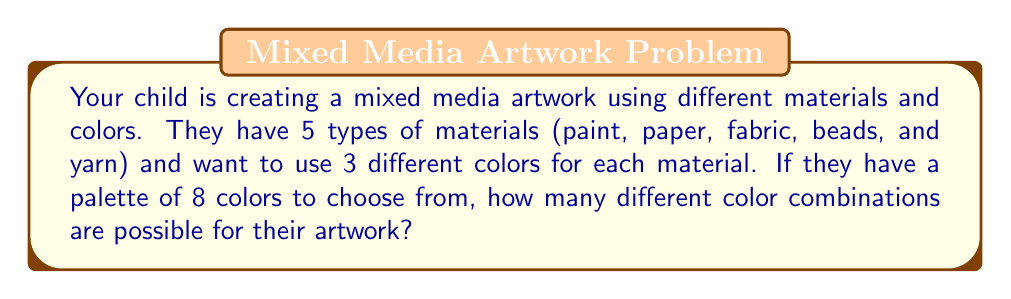Can you answer this question? Let's break this down step-by-step:

1) For each material, your child needs to choose 3 colors out of 8 available colors.

2) This is a combination problem, as the order of selection doesn't matter (e.g., choosing red, blue, green is the same as blue, green, red for a given material).

3) The number of ways to choose 3 colors out of 8 is given by the combination formula:

   $$\binom{8}{3} = \frac{8!}{3!(8-3)!} = \frac{8!}{3!5!}$$

4) Calculating this:
   $$\frac{8 * 7 * 6 * 5!}{(3 * 2 * 1) * 5!} = \frac{336}{6} = 56$$

5) So for each material, there are 56 possible color combinations.

6) Since there are 5 different materials, and each material's color choice is independent of the others, we multiply the number of possibilities for each material:

   $$56 * 56 * 56 * 56 * 56 = 56^5$$

7) Calculate $56^5$:
   $$56^5 = 550,731,776$$

Therefore, the total number of possible color combinations for the entire artwork is 550,731,776.
Answer: $56^5 = 550,731,776$ possible color combinations 